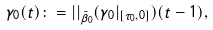<formula> <loc_0><loc_0><loc_500><loc_500>\gamma _ { 0 } ( t ) \colon = | | _ { { \bar { \beta } } _ { 0 } } ( \gamma _ { 0 } | _ { [ \tau _ { 0 } , 0 ] } ) ( t - 1 ) ,</formula> 